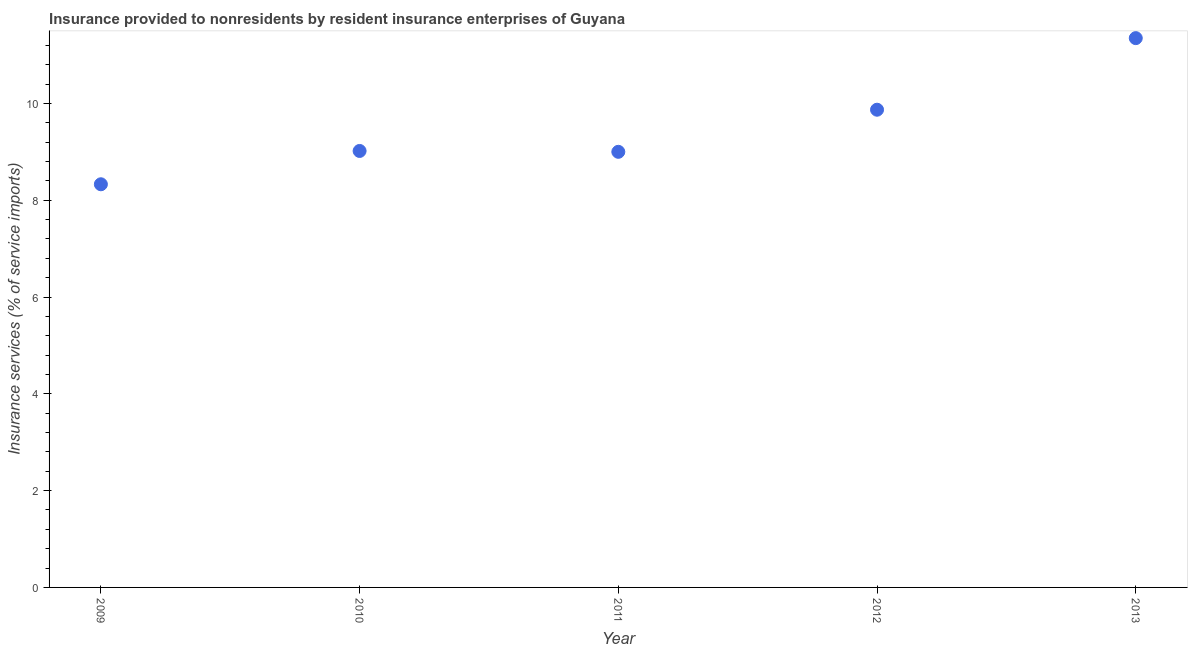What is the insurance and financial services in 2012?
Make the answer very short. 9.87. Across all years, what is the maximum insurance and financial services?
Your response must be concise. 11.35. Across all years, what is the minimum insurance and financial services?
Offer a very short reply. 8.33. What is the sum of the insurance and financial services?
Your response must be concise. 47.56. What is the difference between the insurance and financial services in 2010 and 2011?
Provide a short and direct response. 0.02. What is the average insurance and financial services per year?
Provide a short and direct response. 9.51. What is the median insurance and financial services?
Your response must be concise. 9.02. In how many years, is the insurance and financial services greater than 9.6 %?
Make the answer very short. 2. Do a majority of the years between 2009 and 2010 (inclusive) have insurance and financial services greater than 10.8 %?
Offer a terse response. No. What is the ratio of the insurance and financial services in 2009 to that in 2011?
Make the answer very short. 0.93. Is the insurance and financial services in 2009 less than that in 2013?
Offer a terse response. Yes. What is the difference between the highest and the second highest insurance and financial services?
Offer a terse response. 1.48. What is the difference between the highest and the lowest insurance and financial services?
Offer a terse response. 3.02. In how many years, is the insurance and financial services greater than the average insurance and financial services taken over all years?
Ensure brevity in your answer.  2. How many years are there in the graph?
Your answer should be very brief. 5. What is the title of the graph?
Ensure brevity in your answer.  Insurance provided to nonresidents by resident insurance enterprises of Guyana. What is the label or title of the Y-axis?
Your answer should be compact. Insurance services (% of service imports). What is the Insurance services (% of service imports) in 2009?
Ensure brevity in your answer.  8.33. What is the Insurance services (% of service imports) in 2010?
Ensure brevity in your answer.  9.02. What is the Insurance services (% of service imports) in 2011?
Offer a very short reply. 9. What is the Insurance services (% of service imports) in 2012?
Your answer should be very brief. 9.87. What is the Insurance services (% of service imports) in 2013?
Make the answer very short. 11.35. What is the difference between the Insurance services (% of service imports) in 2009 and 2010?
Provide a succinct answer. -0.69. What is the difference between the Insurance services (% of service imports) in 2009 and 2011?
Offer a very short reply. -0.67. What is the difference between the Insurance services (% of service imports) in 2009 and 2012?
Make the answer very short. -1.54. What is the difference between the Insurance services (% of service imports) in 2009 and 2013?
Give a very brief answer. -3.02. What is the difference between the Insurance services (% of service imports) in 2010 and 2011?
Your response must be concise. 0.02. What is the difference between the Insurance services (% of service imports) in 2010 and 2012?
Provide a short and direct response. -0.85. What is the difference between the Insurance services (% of service imports) in 2010 and 2013?
Offer a terse response. -2.33. What is the difference between the Insurance services (% of service imports) in 2011 and 2012?
Your response must be concise. -0.87. What is the difference between the Insurance services (% of service imports) in 2011 and 2013?
Make the answer very short. -2.35. What is the difference between the Insurance services (% of service imports) in 2012 and 2013?
Your response must be concise. -1.48. What is the ratio of the Insurance services (% of service imports) in 2009 to that in 2010?
Your answer should be compact. 0.92. What is the ratio of the Insurance services (% of service imports) in 2009 to that in 2011?
Your response must be concise. 0.93. What is the ratio of the Insurance services (% of service imports) in 2009 to that in 2012?
Provide a short and direct response. 0.84. What is the ratio of the Insurance services (% of service imports) in 2009 to that in 2013?
Offer a terse response. 0.73. What is the ratio of the Insurance services (% of service imports) in 2010 to that in 2011?
Your answer should be very brief. 1. What is the ratio of the Insurance services (% of service imports) in 2010 to that in 2012?
Your answer should be compact. 0.91. What is the ratio of the Insurance services (% of service imports) in 2010 to that in 2013?
Make the answer very short. 0.8. What is the ratio of the Insurance services (% of service imports) in 2011 to that in 2012?
Make the answer very short. 0.91. What is the ratio of the Insurance services (% of service imports) in 2011 to that in 2013?
Give a very brief answer. 0.79. What is the ratio of the Insurance services (% of service imports) in 2012 to that in 2013?
Provide a succinct answer. 0.87. 